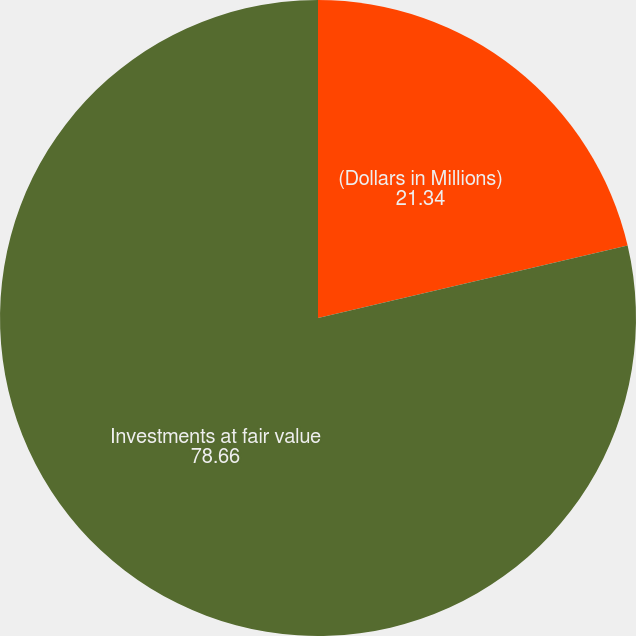<chart> <loc_0><loc_0><loc_500><loc_500><pie_chart><fcel>(Dollars in Millions)<fcel>Investments at fair value<nl><fcel>21.34%<fcel>78.66%<nl></chart> 